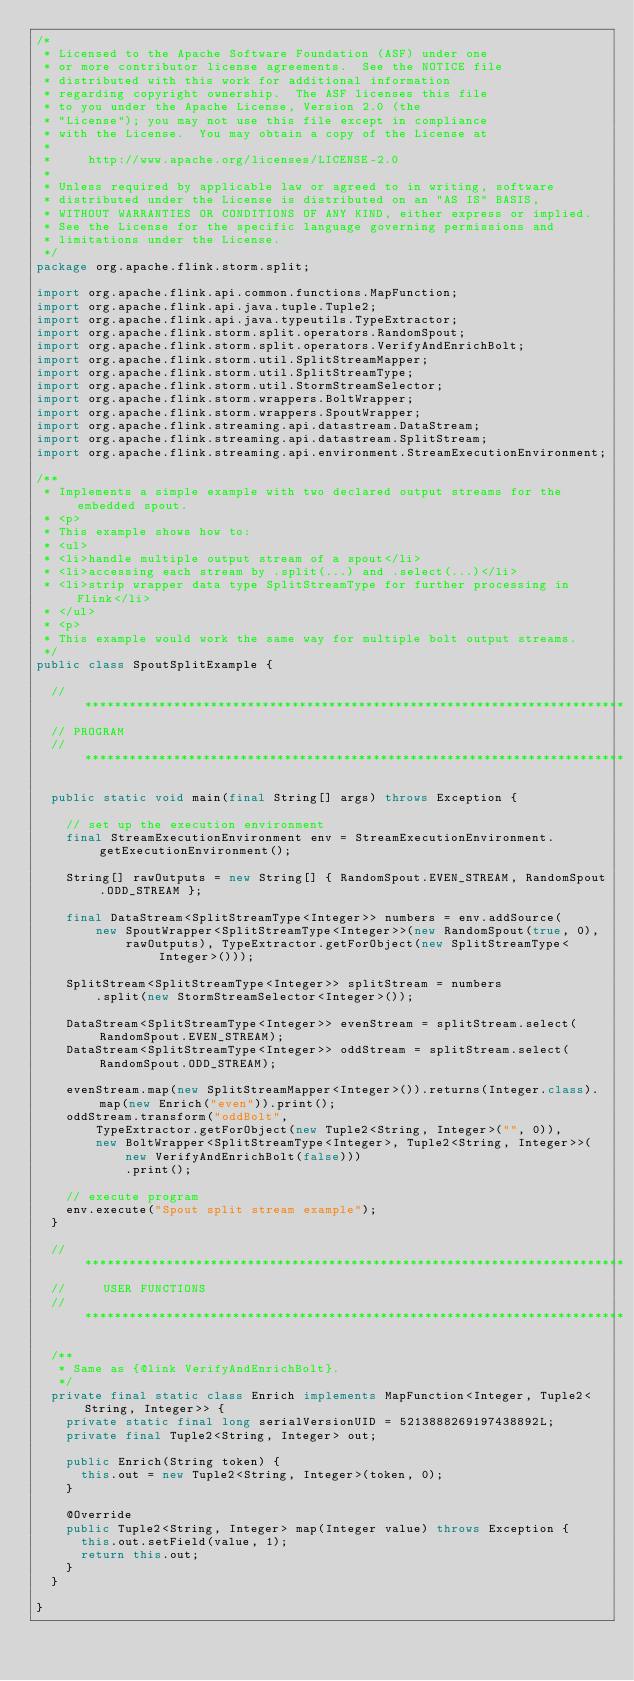Convert code to text. <code><loc_0><loc_0><loc_500><loc_500><_Java_>/*
 * Licensed to the Apache Software Foundation (ASF) under one
 * or more contributor license agreements.  See the NOTICE file
 * distributed with this work for additional information
 * regarding copyright ownership.  The ASF licenses this file
 * to you under the Apache License, Version 2.0 (the
 * "License"); you may not use this file except in compliance
 * with the License.  You may obtain a copy of the License at
 *
 *     http://www.apache.org/licenses/LICENSE-2.0
 *
 * Unless required by applicable law or agreed to in writing, software
 * distributed under the License is distributed on an "AS IS" BASIS,
 * WITHOUT WARRANTIES OR CONDITIONS OF ANY KIND, either express or implied.
 * See the License for the specific language governing permissions and
 * limitations under the License.
 */
package org.apache.flink.storm.split;

import org.apache.flink.api.common.functions.MapFunction;
import org.apache.flink.api.java.tuple.Tuple2;
import org.apache.flink.api.java.typeutils.TypeExtractor;
import org.apache.flink.storm.split.operators.RandomSpout;
import org.apache.flink.storm.split.operators.VerifyAndEnrichBolt;
import org.apache.flink.storm.util.SplitStreamMapper;
import org.apache.flink.storm.util.SplitStreamType;
import org.apache.flink.storm.util.StormStreamSelector;
import org.apache.flink.storm.wrappers.BoltWrapper;
import org.apache.flink.storm.wrappers.SpoutWrapper;
import org.apache.flink.streaming.api.datastream.DataStream;
import org.apache.flink.streaming.api.datastream.SplitStream;
import org.apache.flink.streaming.api.environment.StreamExecutionEnvironment;

/**
 * Implements a simple example with two declared output streams for the embedded spout.
 * <p>
 * This example shows how to:
 * <ul>
 * <li>handle multiple output stream of a spout</li>
 * <li>accessing each stream by .split(...) and .select(...)</li>
 * <li>strip wrapper data type SplitStreamType for further processing in Flink</li>
 * </ul>
 * <p>
 * This example would work the same way for multiple bolt output streams.
 */
public class SpoutSplitExample {

	// *************************************************************************
	// PROGRAM
	// *************************************************************************

	public static void main(final String[] args) throws Exception {

		// set up the execution environment
		final StreamExecutionEnvironment env = StreamExecutionEnvironment.getExecutionEnvironment();

		String[] rawOutputs = new String[] { RandomSpout.EVEN_STREAM, RandomSpout.ODD_STREAM };

		final DataStream<SplitStreamType<Integer>> numbers = env.addSource(
				new SpoutWrapper<SplitStreamType<Integer>>(new RandomSpout(true, 0),
						rawOutputs), TypeExtractor.getForObject(new SplitStreamType<Integer>()));

		SplitStream<SplitStreamType<Integer>> splitStream = numbers
				.split(new StormStreamSelector<Integer>());

		DataStream<SplitStreamType<Integer>> evenStream = splitStream.select(RandomSpout.EVEN_STREAM);
		DataStream<SplitStreamType<Integer>> oddStream = splitStream.select(RandomSpout.ODD_STREAM);

		evenStream.map(new SplitStreamMapper<Integer>()).returns(Integer.class).map(new Enrich("even")).print();
		oddStream.transform("oddBolt",
				TypeExtractor.getForObject(new Tuple2<String, Integer>("", 0)),
				new BoltWrapper<SplitStreamType<Integer>, Tuple2<String, Integer>>(
						new VerifyAndEnrichBolt(false)))
						.print();

		// execute program
		env.execute("Spout split stream example");
	}

	// *************************************************************************
	//     USER FUNCTIONS
	// *************************************************************************

	/**
	 * Same as {@link VerifyAndEnrichBolt}.
	 */
	private final static class Enrich implements MapFunction<Integer, Tuple2<String, Integer>> {
		private static final long serialVersionUID = 5213888269197438892L;
		private final Tuple2<String, Integer> out;

		public Enrich(String token) {
			this.out = new Tuple2<String, Integer>(token, 0);
		}

		@Override
		public Tuple2<String, Integer> map(Integer value) throws Exception {
			this.out.setField(value, 1);
			return this.out;
		}
	}

}
</code> 